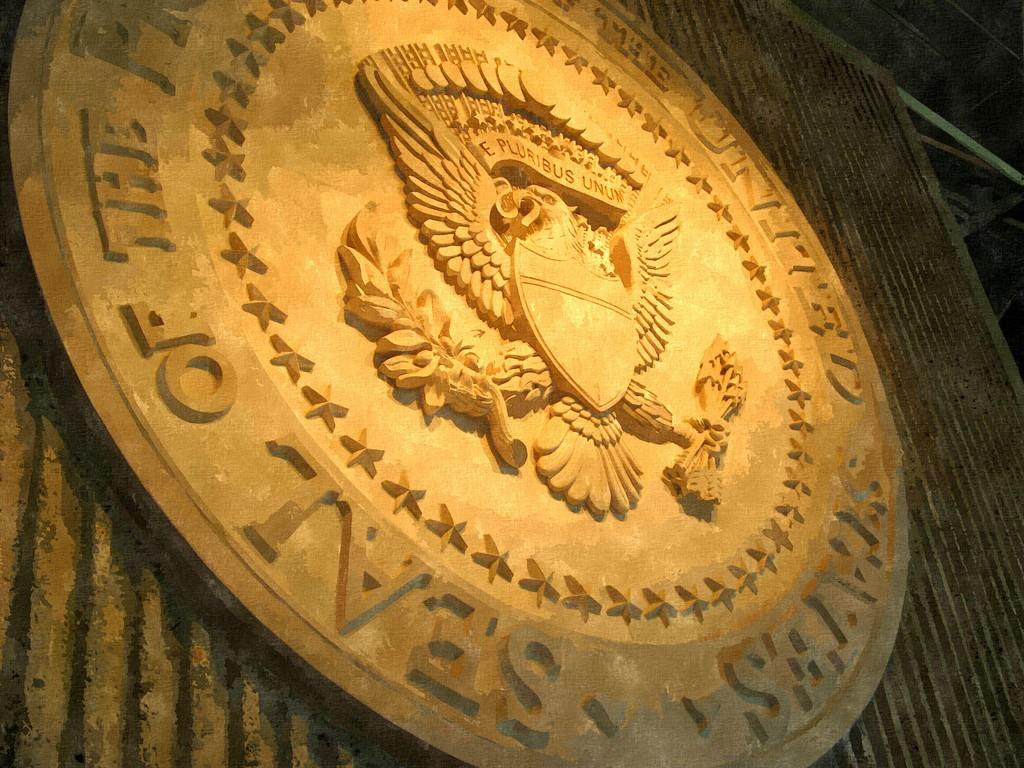<image>
Render a clear and concise summary of the photo. The Seal of the President of the United States looks to be carved from wood. 